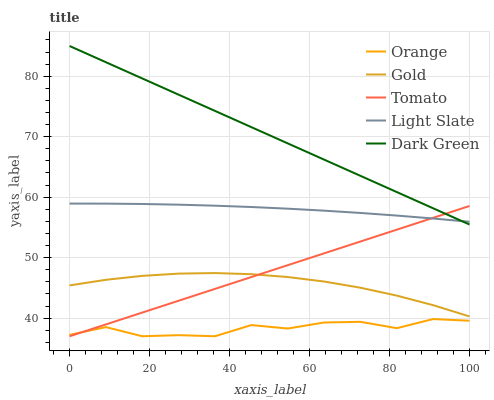Does Orange have the minimum area under the curve?
Answer yes or no. Yes. Does Dark Green have the maximum area under the curve?
Answer yes or no. Yes. Does Tomato have the minimum area under the curve?
Answer yes or no. No. Does Tomato have the maximum area under the curve?
Answer yes or no. No. Is Tomato the smoothest?
Answer yes or no. Yes. Is Orange the roughest?
Answer yes or no. Yes. Is Light Slate the smoothest?
Answer yes or no. No. Is Light Slate the roughest?
Answer yes or no. No. Does Orange have the lowest value?
Answer yes or no. Yes. Does Light Slate have the lowest value?
Answer yes or no. No. Does Dark Green have the highest value?
Answer yes or no. Yes. Does Tomato have the highest value?
Answer yes or no. No. Is Orange less than Gold?
Answer yes or no. Yes. Is Dark Green greater than Gold?
Answer yes or no. Yes. Does Tomato intersect Light Slate?
Answer yes or no. Yes. Is Tomato less than Light Slate?
Answer yes or no. No. Is Tomato greater than Light Slate?
Answer yes or no. No. Does Orange intersect Gold?
Answer yes or no. No. 